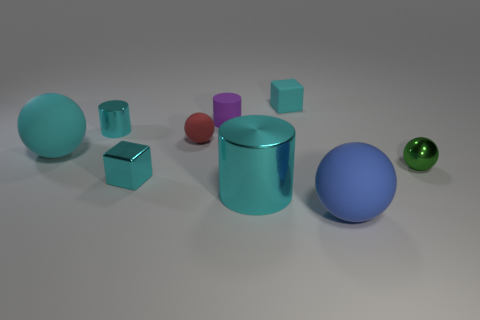What is the size of the metallic block that is the same color as the tiny matte cube?
Provide a succinct answer. Small. Are there any small cyan blocks that have the same material as the tiny purple thing?
Ensure brevity in your answer.  Yes. What number of brown objects are either metallic balls or metallic objects?
Make the answer very short. 0. What size is the matte ball that is both in front of the tiny red thing and behind the blue sphere?
Make the answer very short. Large. Are there more rubber spheres on the left side of the tiny purple thing than small cyan objects?
Your answer should be very brief. No. How many cylinders are either shiny objects or cyan shiny things?
Offer a terse response. 2. The matte object that is both behind the cyan ball and in front of the tiny matte cylinder has what shape?
Offer a very short reply. Sphere. Are there the same number of tiny purple objects on the left side of the tiny rubber cylinder and small green metal objects left of the green shiny thing?
Ensure brevity in your answer.  Yes. What number of things are either large matte things or small gray cylinders?
Ensure brevity in your answer.  2. What is the color of the rubber ball that is the same size as the blue thing?
Provide a succinct answer. Cyan. 